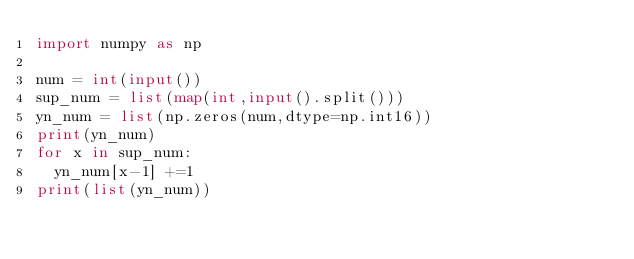<code> <loc_0><loc_0><loc_500><loc_500><_Python_>import numpy as np

num = int(input())
sup_num = list(map(int,input().split()))
yn_num = list(np.zeros(num,dtype=np.int16))
print(yn_num)
for x in sup_num:
  yn_num[x-1] +=1
print(list(yn_num))
</code> 